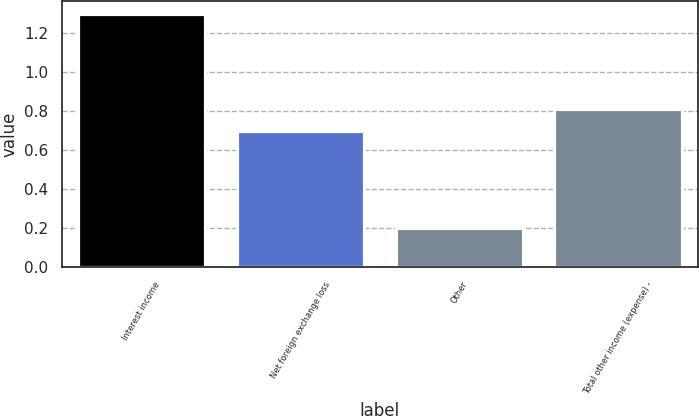Convert chart to OTSL. <chart><loc_0><loc_0><loc_500><loc_500><bar_chart><fcel>Interest income<fcel>Net foreign exchange loss<fcel>Other<fcel>Total other income (expense) -<nl><fcel>1.3<fcel>0.7<fcel>0.2<fcel>0.81<nl></chart> 